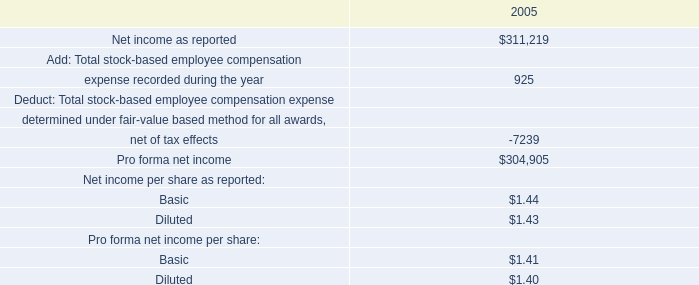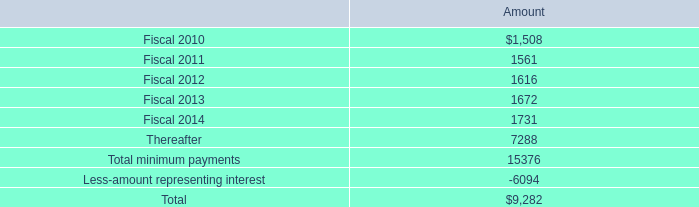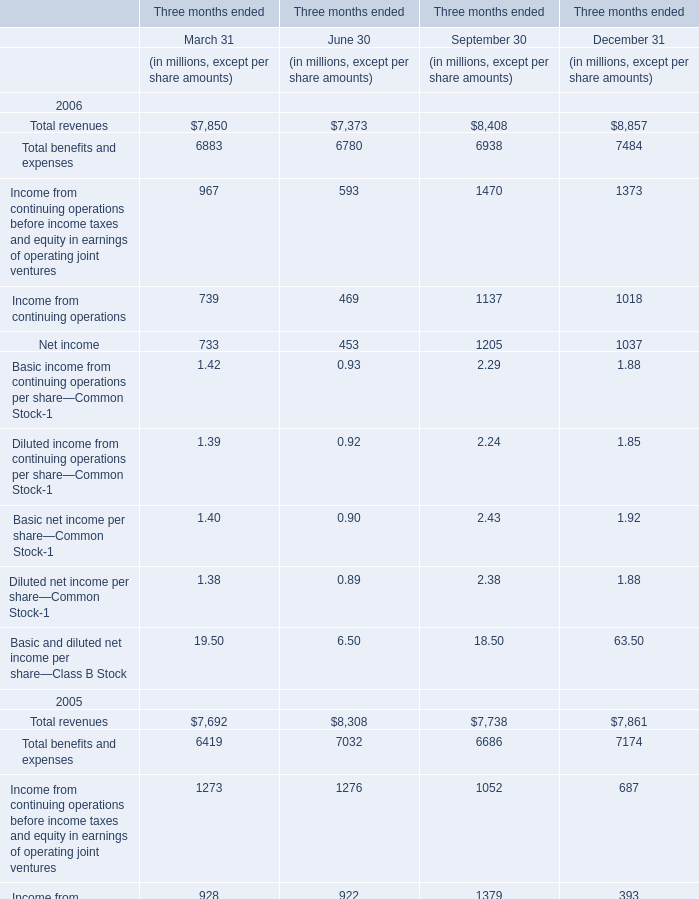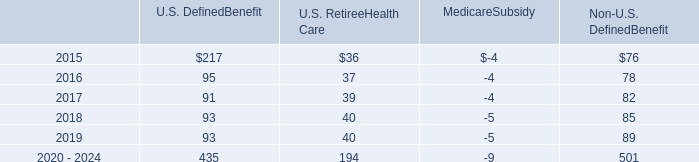Does Total revenues keeps increasing each year between December 31 2005 and December 31 2006? 
Answer: yes. 